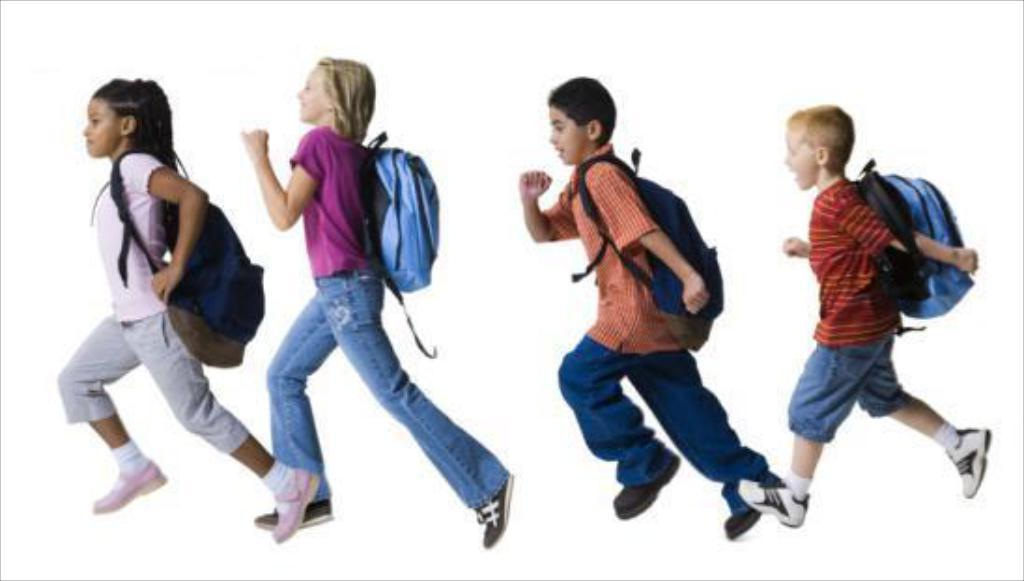What is the main subject of the image? The main subject of the image is kids. What are the kids doing in the image? The kids are running in the image. What are the kids wearing while running? The kids are wearing bags in the image. What type of plate is being used by the kids to communicate in the image? There is no plate present in the image, and the kids are not using any plate to communicate. 